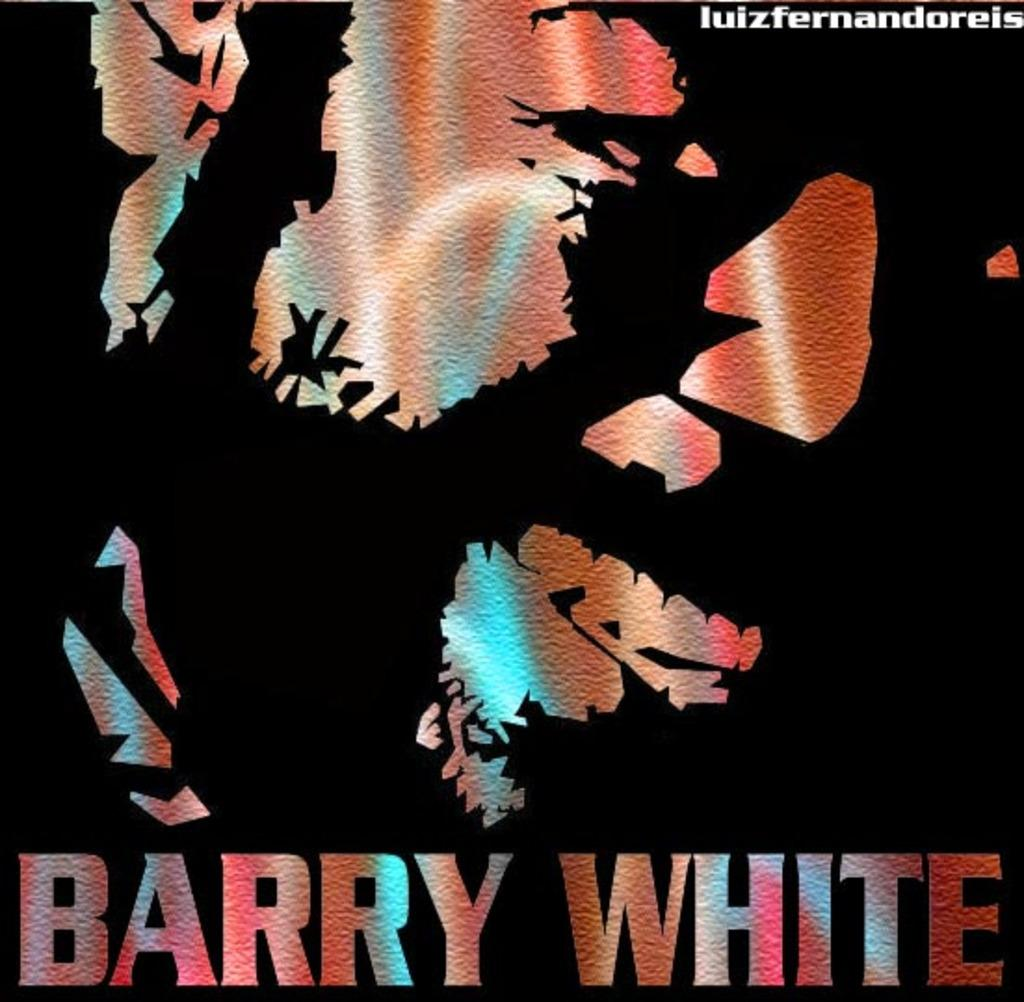What type of poster is depicted in the image? The poster is a graphic poster. What text is written at the bottom of the poster? The text "BARRY WHITE" is written at the bottom of the poster. Can you hear the laughter coming from the poster? There is no laughter present in the image, as it is a still poster featuring text and graphics. 